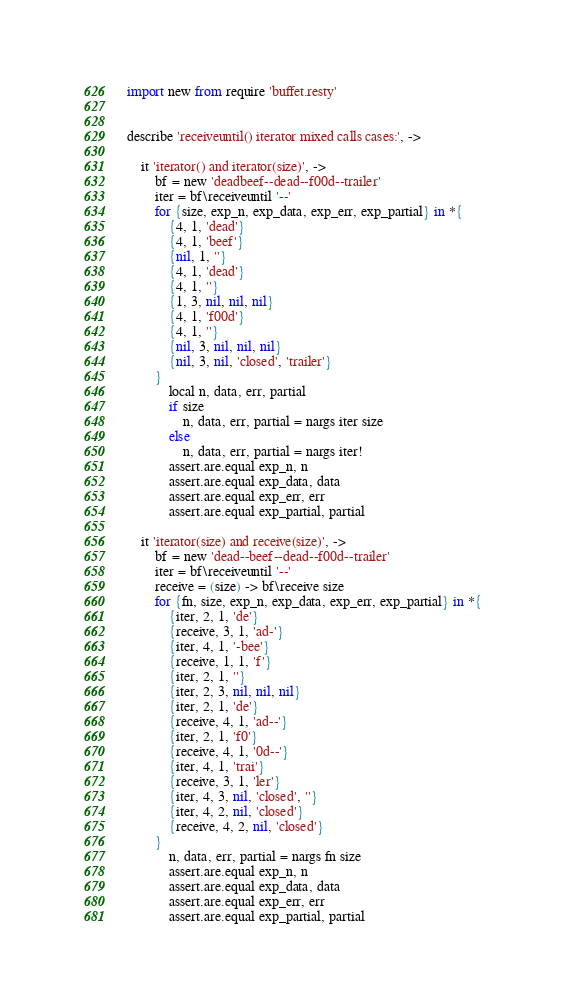<code> <loc_0><loc_0><loc_500><loc_500><_MoonScript_>import new from require 'buffet.resty'


describe 'receiveuntil() iterator mixed calls cases:', ->

    it 'iterator() and iterator(size)', ->
        bf = new 'deadbeef--dead--f00d--trailer'
        iter = bf\receiveuntil '--'
        for {size, exp_n, exp_data, exp_err, exp_partial} in *{
            {4, 1, 'dead'}
            {4, 1, 'beef'}
            {nil, 1, ''}
            {4, 1, 'dead'}
            {4, 1, ''}
            {1, 3, nil, nil, nil}
            {4, 1, 'f00d'}
            {4, 1, ''}
            {nil, 3, nil, nil, nil}
            {nil, 3, nil, 'closed', 'trailer'}
        }
            local n, data, err, partial
            if size
                n, data, err, partial = nargs iter size
            else
                n, data, err, partial = nargs iter!
            assert.are.equal exp_n, n
            assert.are.equal exp_data, data
            assert.are.equal exp_err, err
            assert.are.equal exp_partial, partial

    it 'iterator(size) and receive(size)', ->
        bf = new 'dead--beef--dead--f00d--trailer'
        iter = bf\receiveuntil '--'
        receive = (size) -> bf\receive size
        for {fn, size, exp_n, exp_data, exp_err, exp_partial} in *{
            {iter, 2, 1, 'de'}
            {receive, 3, 1, 'ad-'}
            {iter, 4, 1, '-bee'}
            {receive, 1, 1, 'f'}
            {iter, 2, 1, ''}
            {iter, 2, 3, nil, nil, nil}
            {iter, 2, 1, 'de'}
            {receive, 4, 1, 'ad--'}
            {iter, 2, 1, 'f0'}
            {receive, 4, 1, '0d--'}
            {iter, 4, 1, 'trai'}
            {receive, 3, 1, 'ler'}
            {iter, 4, 3, nil, 'closed', ''}
            {iter, 4, 2, nil, 'closed'}
            {receive, 4, 2, nil, 'closed'}
        }
            n, data, err, partial = nargs fn size
            assert.are.equal exp_n, n
            assert.are.equal exp_data, data
            assert.are.equal exp_err, err
            assert.are.equal exp_partial, partial
</code> 